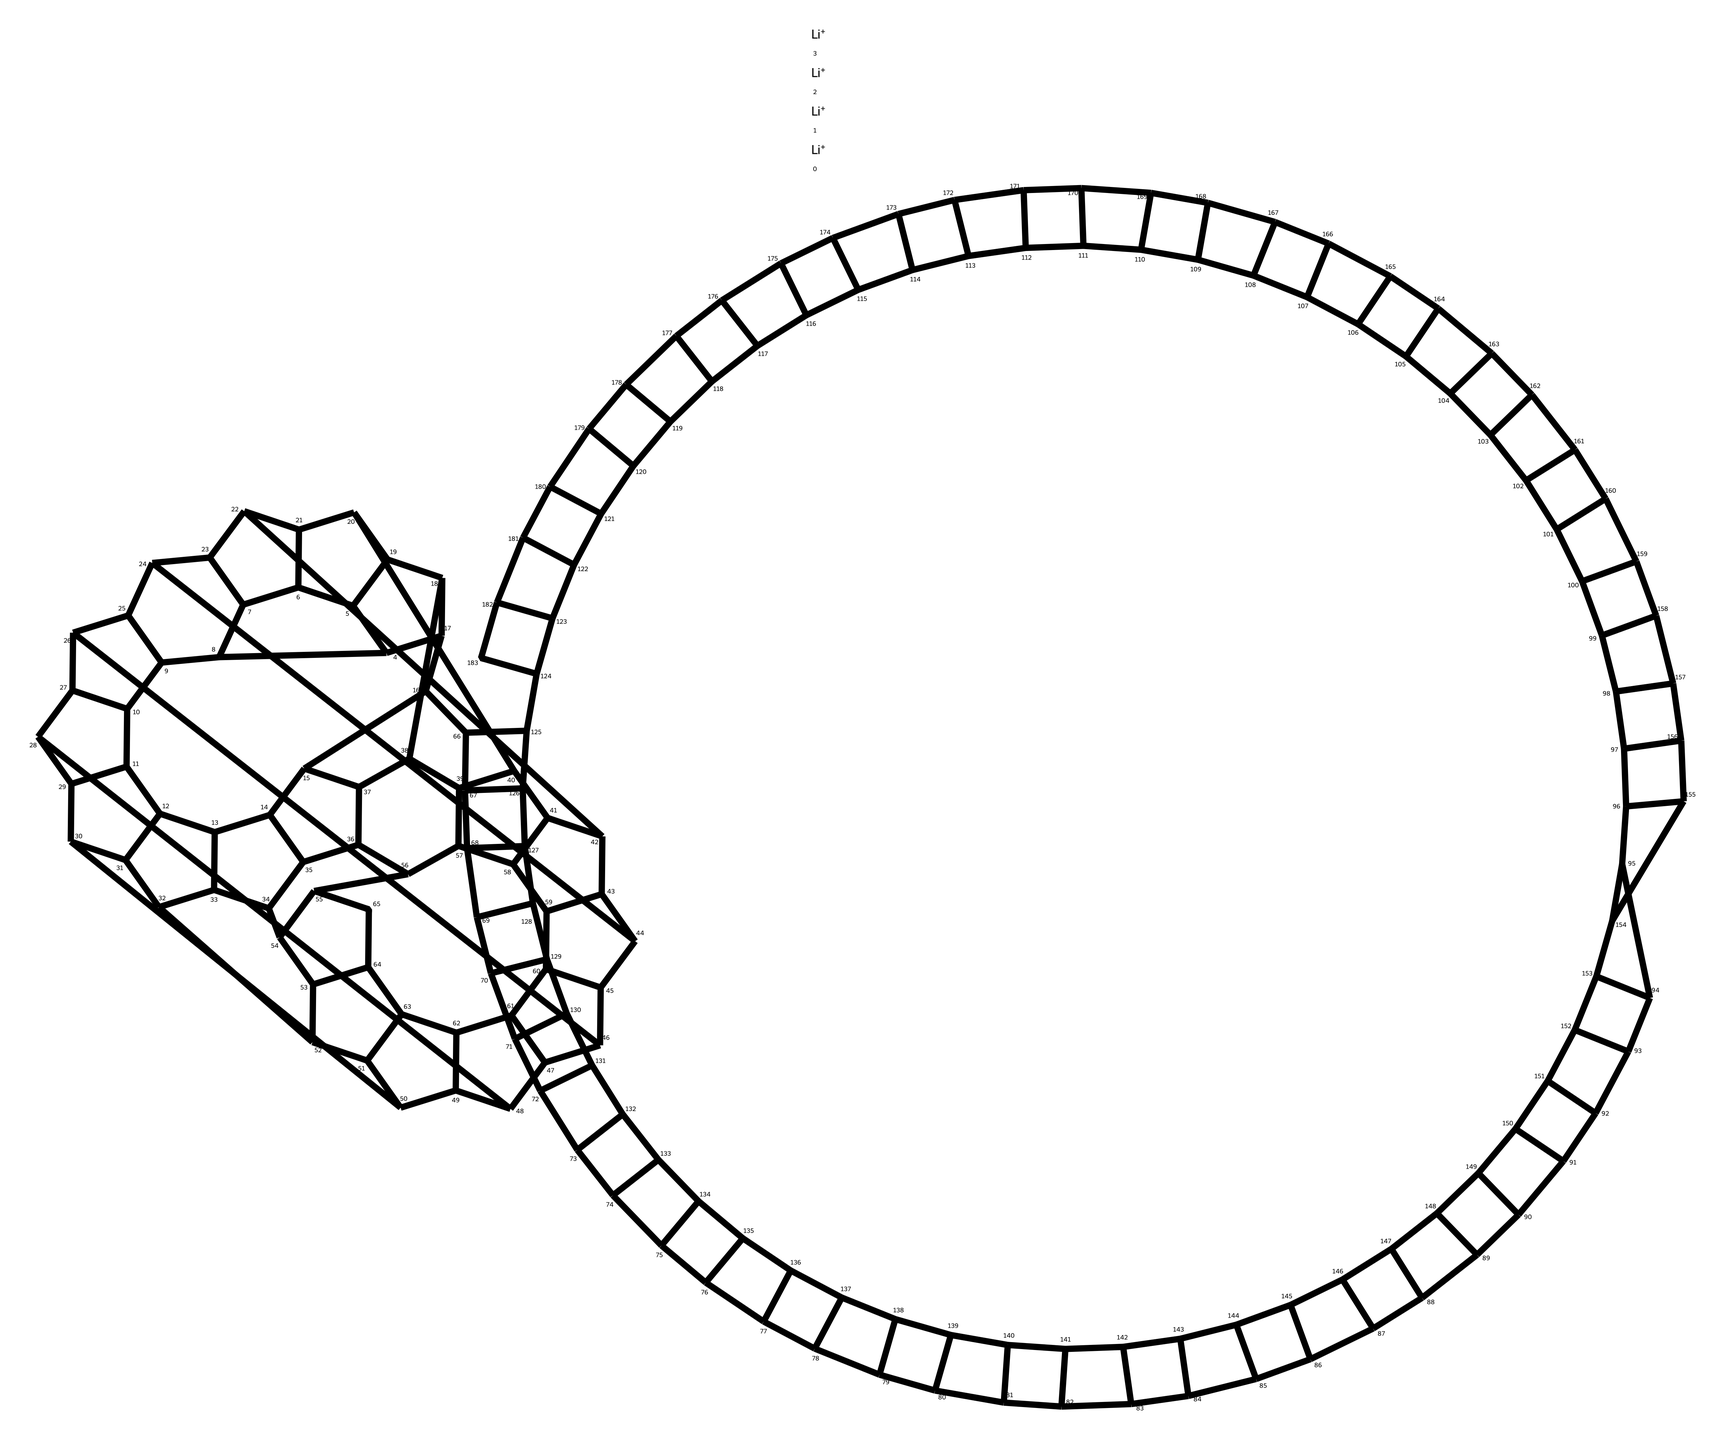What is the total number of lithium atoms in lithium fulleride? The chemical structure indicates that there are four lithium atoms represented by the [Li+] notation.
Answer: four How many carbon atoms are present in lithium fulleride? The chemical structure suggests multiple carbon connections, which together sum to sixty carbon atoms, shown in the formula.
Answer: sixty What type of chemical is lithium fulleride? Given its structure, which includes a fullerenic shape and lithium ions, it is classified as a fulleride.
Answer: fulleride What property does the structure of lithium fulleride suggest for lightweight sports gear? The low molecular weight and stable structure imply lightweight and durable characteristics, ideal for sports gear.
Answer: lightweight What is the unique structural feature of fullerides like lithium fulleride? Fullerides feature a cage-like structure formed by interconnected carbon atoms, which contributes to their unique properties.
Answer: cage-like structure How many Li+ cations are connected to the carbon structure in lithium fulleride? By examining the structure, one can identify that there are four lithium cations connected to the carbon framework.
Answer: four What is the significance of the carbon count in determining the stability of lithium fulleride? The high number of carbon atoms, specifically sixty, provides enhanced stability and integrity to the molecular structure of lithium fulleride.
Answer: enhanced stability 